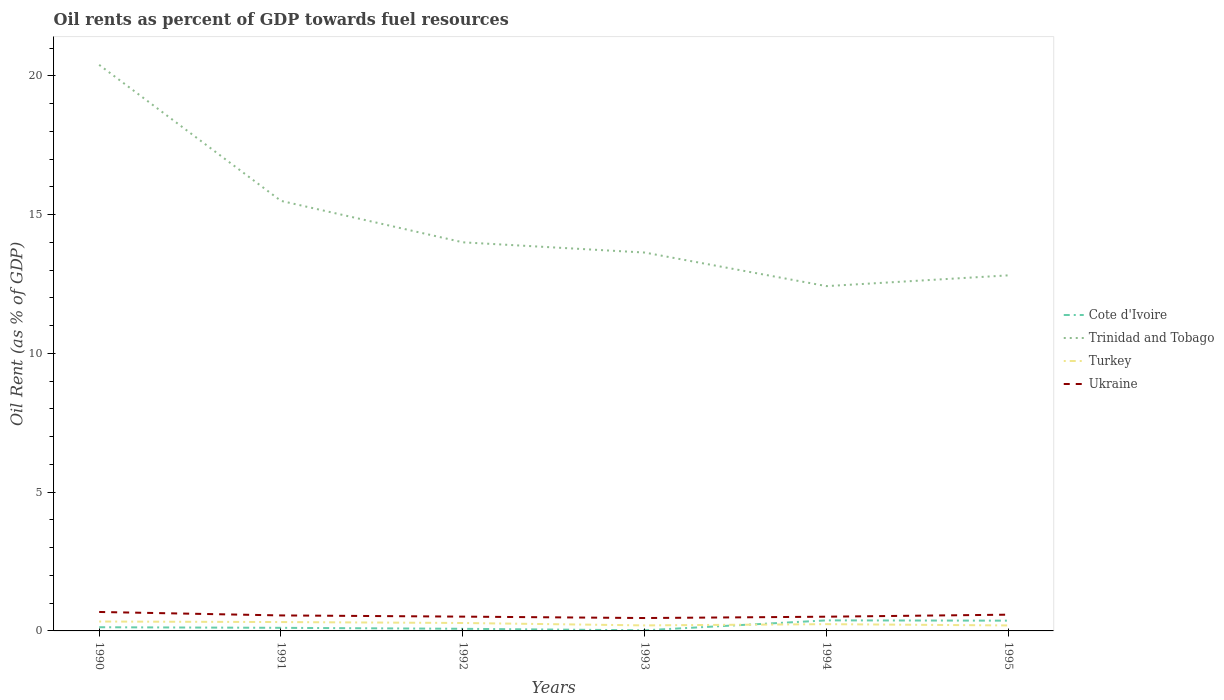Across all years, what is the maximum oil rent in Trinidad and Tobago?
Offer a very short reply. 12.42. What is the total oil rent in Turkey in the graph?
Offer a terse response. 0.12. What is the difference between the highest and the second highest oil rent in Ukraine?
Your response must be concise. 0.22. What is the difference between the highest and the lowest oil rent in Ukraine?
Make the answer very short. 3. How many lines are there?
Your answer should be compact. 4. How many years are there in the graph?
Your answer should be compact. 6. Are the values on the major ticks of Y-axis written in scientific E-notation?
Give a very brief answer. No. Does the graph contain grids?
Provide a succinct answer. No. Where does the legend appear in the graph?
Ensure brevity in your answer.  Center right. How are the legend labels stacked?
Make the answer very short. Vertical. What is the title of the graph?
Your answer should be compact. Oil rents as percent of GDP towards fuel resources. What is the label or title of the X-axis?
Give a very brief answer. Years. What is the label or title of the Y-axis?
Keep it short and to the point. Oil Rent (as % of GDP). What is the Oil Rent (as % of GDP) in Cote d'Ivoire in 1990?
Offer a very short reply. 0.13. What is the Oil Rent (as % of GDP) in Trinidad and Tobago in 1990?
Provide a short and direct response. 20.4. What is the Oil Rent (as % of GDP) of Turkey in 1990?
Your response must be concise. 0.34. What is the Oil Rent (as % of GDP) in Ukraine in 1990?
Your response must be concise. 0.68. What is the Oil Rent (as % of GDP) in Cote d'Ivoire in 1991?
Your answer should be compact. 0.11. What is the Oil Rent (as % of GDP) in Trinidad and Tobago in 1991?
Your answer should be compact. 15.5. What is the Oil Rent (as % of GDP) of Turkey in 1991?
Give a very brief answer. 0.32. What is the Oil Rent (as % of GDP) in Ukraine in 1991?
Offer a very short reply. 0.56. What is the Oil Rent (as % of GDP) of Cote d'Ivoire in 1992?
Give a very brief answer. 0.08. What is the Oil Rent (as % of GDP) of Trinidad and Tobago in 1992?
Make the answer very short. 14. What is the Oil Rent (as % of GDP) in Turkey in 1992?
Give a very brief answer. 0.29. What is the Oil Rent (as % of GDP) in Ukraine in 1992?
Ensure brevity in your answer.  0.52. What is the Oil Rent (as % of GDP) in Cote d'Ivoire in 1993?
Offer a very short reply. 0.02. What is the Oil Rent (as % of GDP) of Trinidad and Tobago in 1993?
Keep it short and to the point. 13.63. What is the Oil Rent (as % of GDP) of Turkey in 1993?
Ensure brevity in your answer.  0.2. What is the Oil Rent (as % of GDP) of Ukraine in 1993?
Keep it short and to the point. 0.46. What is the Oil Rent (as % of GDP) of Cote d'Ivoire in 1994?
Give a very brief answer. 0.38. What is the Oil Rent (as % of GDP) in Trinidad and Tobago in 1994?
Your response must be concise. 12.42. What is the Oil Rent (as % of GDP) of Turkey in 1994?
Your response must be concise. 0.24. What is the Oil Rent (as % of GDP) of Ukraine in 1994?
Ensure brevity in your answer.  0.51. What is the Oil Rent (as % of GDP) of Cote d'Ivoire in 1995?
Give a very brief answer. 0.37. What is the Oil Rent (as % of GDP) of Trinidad and Tobago in 1995?
Make the answer very short. 12.81. What is the Oil Rent (as % of GDP) of Turkey in 1995?
Your answer should be very brief. 0.2. What is the Oil Rent (as % of GDP) in Ukraine in 1995?
Provide a succinct answer. 0.59. Across all years, what is the maximum Oil Rent (as % of GDP) in Cote d'Ivoire?
Offer a very short reply. 0.38. Across all years, what is the maximum Oil Rent (as % of GDP) of Trinidad and Tobago?
Offer a terse response. 20.4. Across all years, what is the maximum Oil Rent (as % of GDP) in Turkey?
Make the answer very short. 0.34. Across all years, what is the maximum Oil Rent (as % of GDP) in Ukraine?
Your answer should be compact. 0.68. Across all years, what is the minimum Oil Rent (as % of GDP) of Cote d'Ivoire?
Provide a short and direct response. 0.02. Across all years, what is the minimum Oil Rent (as % of GDP) in Trinidad and Tobago?
Your answer should be very brief. 12.42. Across all years, what is the minimum Oil Rent (as % of GDP) in Turkey?
Your response must be concise. 0.2. Across all years, what is the minimum Oil Rent (as % of GDP) in Ukraine?
Your answer should be very brief. 0.46. What is the total Oil Rent (as % of GDP) in Cote d'Ivoire in the graph?
Ensure brevity in your answer.  1.09. What is the total Oil Rent (as % of GDP) of Trinidad and Tobago in the graph?
Your response must be concise. 88.76. What is the total Oil Rent (as % of GDP) of Turkey in the graph?
Your answer should be compact. 1.58. What is the total Oil Rent (as % of GDP) of Ukraine in the graph?
Ensure brevity in your answer.  3.32. What is the difference between the Oil Rent (as % of GDP) of Cote d'Ivoire in 1990 and that in 1991?
Ensure brevity in your answer.  0.02. What is the difference between the Oil Rent (as % of GDP) of Trinidad and Tobago in 1990 and that in 1991?
Provide a short and direct response. 4.9. What is the difference between the Oil Rent (as % of GDP) in Turkey in 1990 and that in 1991?
Offer a very short reply. 0.02. What is the difference between the Oil Rent (as % of GDP) in Ukraine in 1990 and that in 1991?
Provide a succinct answer. 0.12. What is the difference between the Oil Rent (as % of GDP) in Cote d'Ivoire in 1990 and that in 1992?
Make the answer very short. 0.06. What is the difference between the Oil Rent (as % of GDP) of Trinidad and Tobago in 1990 and that in 1992?
Your answer should be compact. 6.39. What is the difference between the Oil Rent (as % of GDP) in Turkey in 1990 and that in 1992?
Your answer should be very brief. 0.05. What is the difference between the Oil Rent (as % of GDP) of Ukraine in 1990 and that in 1992?
Keep it short and to the point. 0.17. What is the difference between the Oil Rent (as % of GDP) of Cote d'Ivoire in 1990 and that in 1993?
Make the answer very short. 0.11. What is the difference between the Oil Rent (as % of GDP) in Trinidad and Tobago in 1990 and that in 1993?
Make the answer very short. 6.76. What is the difference between the Oil Rent (as % of GDP) of Turkey in 1990 and that in 1993?
Your answer should be very brief. 0.14. What is the difference between the Oil Rent (as % of GDP) of Ukraine in 1990 and that in 1993?
Your answer should be compact. 0.22. What is the difference between the Oil Rent (as % of GDP) in Cote d'Ivoire in 1990 and that in 1994?
Offer a very short reply. -0.25. What is the difference between the Oil Rent (as % of GDP) in Trinidad and Tobago in 1990 and that in 1994?
Provide a succinct answer. 7.97. What is the difference between the Oil Rent (as % of GDP) of Turkey in 1990 and that in 1994?
Your answer should be compact. 0.09. What is the difference between the Oil Rent (as % of GDP) of Ukraine in 1990 and that in 1994?
Provide a short and direct response. 0.17. What is the difference between the Oil Rent (as % of GDP) in Cote d'Ivoire in 1990 and that in 1995?
Provide a succinct answer. -0.24. What is the difference between the Oil Rent (as % of GDP) in Trinidad and Tobago in 1990 and that in 1995?
Offer a very short reply. 7.58. What is the difference between the Oil Rent (as % of GDP) of Turkey in 1990 and that in 1995?
Your response must be concise. 0.14. What is the difference between the Oil Rent (as % of GDP) of Ukraine in 1990 and that in 1995?
Your answer should be very brief. 0.1. What is the difference between the Oil Rent (as % of GDP) of Cote d'Ivoire in 1991 and that in 1992?
Your answer should be very brief. 0.04. What is the difference between the Oil Rent (as % of GDP) in Trinidad and Tobago in 1991 and that in 1992?
Your answer should be very brief. 1.49. What is the difference between the Oil Rent (as % of GDP) of Turkey in 1991 and that in 1992?
Keep it short and to the point. 0.03. What is the difference between the Oil Rent (as % of GDP) in Ukraine in 1991 and that in 1992?
Keep it short and to the point. 0.04. What is the difference between the Oil Rent (as % of GDP) in Cote d'Ivoire in 1991 and that in 1993?
Offer a very short reply. 0.09. What is the difference between the Oil Rent (as % of GDP) of Trinidad and Tobago in 1991 and that in 1993?
Provide a short and direct response. 1.86. What is the difference between the Oil Rent (as % of GDP) of Turkey in 1991 and that in 1993?
Offer a very short reply. 0.12. What is the difference between the Oil Rent (as % of GDP) of Ukraine in 1991 and that in 1993?
Offer a terse response. 0.09. What is the difference between the Oil Rent (as % of GDP) in Cote d'Ivoire in 1991 and that in 1994?
Provide a short and direct response. -0.27. What is the difference between the Oil Rent (as % of GDP) of Trinidad and Tobago in 1991 and that in 1994?
Provide a succinct answer. 3.07. What is the difference between the Oil Rent (as % of GDP) in Turkey in 1991 and that in 1994?
Your answer should be very brief. 0.08. What is the difference between the Oil Rent (as % of GDP) in Ukraine in 1991 and that in 1994?
Offer a very short reply. 0.05. What is the difference between the Oil Rent (as % of GDP) in Cote d'Ivoire in 1991 and that in 1995?
Make the answer very short. -0.26. What is the difference between the Oil Rent (as % of GDP) in Trinidad and Tobago in 1991 and that in 1995?
Offer a terse response. 2.68. What is the difference between the Oil Rent (as % of GDP) in Turkey in 1991 and that in 1995?
Keep it short and to the point. 0.12. What is the difference between the Oil Rent (as % of GDP) of Ukraine in 1991 and that in 1995?
Your answer should be compact. -0.03. What is the difference between the Oil Rent (as % of GDP) of Cote d'Ivoire in 1992 and that in 1993?
Your response must be concise. 0.05. What is the difference between the Oil Rent (as % of GDP) in Trinidad and Tobago in 1992 and that in 1993?
Ensure brevity in your answer.  0.37. What is the difference between the Oil Rent (as % of GDP) of Turkey in 1992 and that in 1993?
Make the answer very short. 0.09. What is the difference between the Oil Rent (as % of GDP) of Ukraine in 1992 and that in 1993?
Make the answer very short. 0.05. What is the difference between the Oil Rent (as % of GDP) in Cote d'Ivoire in 1992 and that in 1994?
Make the answer very short. -0.3. What is the difference between the Oil Rent (as % of GDP) of Trinidad and Tobago in 1992 and that in 1994?
Give a very brief answer. 1.58. What is the difference between the Oil Rent (as % of GDP) of Turkey in 1992 and that in 1994?
Keep it short and to the point. 0.04. What is the difference between the Oil Rent (as % of GDP) in Ukraine in 1992 and that in 1994?
Make the answer very short. 0. What is the difference between the Oil Rent (as % of GDP) in Cote d'Ivoire in 1992 and that in 1995?
Provide a short and direct response. -0.29. What is the difference between the Oil Rent (as % of GDP) in Trinidad and Tobago in 1992 and that in 1995?
Ensure brevity in your answer.  1.19. What is the difference between the Oil Rent (as % of GDP) in Turkey in 1992 and that in 1995?
Make the answer very short. 0.09. What is the difference between the Oil Rent (as % of GDP) of Ukraine in 1992 and that in 1995?
Ensure brevity in your answer.  -0.07. What is the difference between the Oil Rent (as % of GDP) in Cote d'Ivoire in 1993 and that in 1994?
Your answer should be very brief. -0.36. What is the difference between the Oil Rent (as % of GDP) in Trinidad and Tobago in 1993 and that in 1994?
Offer a very short reply. 1.21. What is the difference between the Oil Rent (as % of GDP) in Turkey in 1993 and that in 1994?
Your answer should be very brief. -0.04. What is the difference between the Oil Rent (as % of GDP) of Ukraine in 1993 and that in 1994?
Keep it short and to the point. -0.05. What is the difference between the Oil Rent (as % of GDP) of Cote d'Ivoire in 1993 and that in 1995?
Your answer should be very brief. -0.35. What is the difference between the Oil Rent (as % of GDP) in Trinidad and Tobago in 1993 and that in 1995?
Provide a succinct answer. 0.82. What is the difference between the Oil Rent (as % of GDP) of Turkey in 1993 and that in 1995?
Keep it short and to the point. 0. What is the difference between the Oil Rent (as % of GDP) in Ukraine in 1993 and that in 1995?
Keep it short and to the point. -0.12. What is the difference between the Oil Rent (as % of GDP) in Cote d'Ivoire in 1994 and that in 1995?
Offer a terse response. 0.01. What is the difference between the Oil Rent (as % of GDP) in Trinidad and Tobago in 1994 and that in 1995?
Your answer should be compact. -0.39. What is the difference between the Oil Rent (as % of GDP) of Turkey in 1994 and that in 1995?
Make the answer very short. 0.05. What is the difference between the Oil Rent (as % of GDP) in Ukraine in 1994 and that in 1995?
Your answer should be compact. -0.07. What is the difference between the Oil Rent (as % of GDP) of Cote d'Ivoire in 1990 and the Oil Rent (as % of GDP) of Trinidad and Tobago in 1991?
Provide a succinct answer. -15.36. What is the difference between the Oil Rent (as % of GDP) in Cote d'Ivoire in 1990 and the Oil Rent (as % of GDP) in Turkey in 1991?
Provide a succinct answer. -0.19. What is the difference between the Oil Rent (as % of GDP) of Cote d'Ivoire in 1990 and the Oil Rent (as % of GDP) of Ukraine in 1991?
Make the answer very short. -0.43. What is the difference between the Oil Rent (as % of GDP) in Trinidad and Tobago in 1990 and the Oil Rent (as % of GDP) in Turkey in 1991?
Provide a succinct answer. 20.08. What is the difference between the Oil Rent (as % of GDP) in Trinidad and Tobago in 1990 and the Oil Rent (as % of GDP) in Ukraine in 1991?
Your answer should be very brief. 19.84. What is the difference between the Oil Rent (as % of GDP) of Turkey in 1990 and the Oil Rent (as % of GDP) of Ukraine in 1991?
Make the answer very short. -0.22. What is the difference between the Oil Rent (as % of GDP) of Cote d'Ivoire in 1990 and the Oil Rent (as % of GDP) of Trinidad and Tobago in 1992?
Ensure brevity in your answer.  -13.87. What is the difference between the Oil Rent (as % of GDP) in Cote d'Ivoire in 1990 and the Oil Rent (as % of GDP) in Turkey in 1992?
Your answer should be compact. -0.15. What is the difference between the Oil Rent (as % of GDP) in Cote d'Ivoire in 1990 and the Oil Rent (as % of GDP) in Ukraine in 1992?
Keep it short and to the point. -0.38. What is the difference between the Oil Rent (as % of GDP) in Trinidad and Tobago in 1990 and the Oil Rent (as % of GDP) in Turkey in 1992?
Keep it short and to the point. 20.11. What is the difference between the Oil Rent (as % of GDP) of Trinidad and Tobago in 1990 and the Oil Rent (as % of GDP) of Ukraine in 1992?
Make the answer very short. 19.88. What is the difference between the Oil Rent (as % of GDP) of Turkey in 1990 and the Oil Rent (as % of GDP) of Ukraine in 1992?
Your response must be concise. -0.18. What is the difference between the Oil Rent (as % of GDP) in Cote d'Ivoire in 1990 and the Oil Rent (as % of GDP) in Trinidad and Tobago in 1993?
Make the answer very short. -13.5. What is the difference between the Oil Rent (as % of GDP) in Cote d'Ivoire in 1990 and the Oil Rent (as % of GDP) in Turkey in 1993?
Your answer should be compact. -0.07. What is the difference between the Oil Rent (as % of GDP) in Cote d'Ivoire in 1990 and the Oil Rent (as % of GDP) in Ukraine in 1993?
Make the answer very short. -0.33. What is the difference between the Oil Rent (as % of GDP) of Trinidad and Tobago in 1990 and the Oil Rent (as % of GDP) of Turkey in 1993?
Provide a short and direct response. 20.2. What is the difference between the Oil Rent (as % of GDP) in Trinidad and Tobago in 1990 and the Oil Rent (as % of GDP) in Ukraine in 1993?
Offer a very short reply. 19.93. What is the difference between the Oil Rent (as % of GDP) of Turkey in 1990 and the Oil Rent (as % of GDP) of Ukraine in 1993?
Give a very brief answer. -0.13. What is the difference between the Oil Rent (as % of GDP) of Cote d'Ivoire in 1990 and the Oil Rent (as % of GDP) of Trinidad and Tobago in 1994?
Provide a short and direct response. -12.29. What is the difference between the Oil Rent (as % of GDP) of Cote d'Ivoire in 1990 and the Oil Rent (as % of GDP) of Turkey in 1994?
Offer a very short reply. -0.11. What is the difference between the Oil Rent (as % of GDP) in Cote d'Ivoire in 1990 and the Oil Rent (as % of GDP) in Ukraine in 1994?
Give a very brief answer. -0.38. What is the difference between the Oil Rent (as % of GDP) of Trinidad and Tobago in 1990 and the Oil Rent (as % of GDP) of Turkey in 1994?
Offer a very short reply. 20.15. What is the difference between the Oil Rent (as % of GDP) in Trinidad and Tobago in 1990 and the Oil Rent (as % of GDP) in Ukraine in 1994?
Your answer should be compact. 19.88. What is the difference between the Oil Rent (as % of GDP) in Turkey in 1990 and the Oil Rent (as % of GDP) in Ukraine in 1994?
Offer a very short reply. -0.17. What is the difference between the Oil Rent (as % of GDP) in Cote d'Ivoire in 1990 and the Oil Rent (as % of GDP) in Trinidad and Tobago in 1995?
Offer a terse response. -12.68. What is the difference between the Oil Rent (as % of GDP) of Cote d'Ivoire in 1990 and the Oil Rent (as % of GDP) of Turkey in 1995?
Offer a very short reply. -0.06. What is the difference between the Oil Rent (as % of GDP) in Cote d'Ivoire in 1990 and the Oil Rent (as % of GDP) in Ukraine in 1995?
Ensure brevity in your answer.  -0.45. What is the difference between the Oil Rent (as % of GDP) of Trinidad and Tobago in 1990 and the Oil Rent (as % of GDP) of Turkey in 1995?
Ensure brevity in your answer.  20.2. What is the difference between the Oil Rent (as % of GDP) in Trinidad and Tobago in 1990 and the Oil Rent (as % of GDP) in Ukraine in 1995?
Provide a short and direct response. 19.81. What is the difference between the Oil Rent (as % of GDP) in Turkey in 1990 and the Oil Rent (as % of GDP) in Ukraine in 1995?
Keep it short and to the point. -0.25. What is the difference between the Oil Rent (as % of GDP) of Cote d'Ivoire in 1991 and the Oil Rent (as % of GDP) of Trinidad and Tobago in 1992?
Make the answer very short. -13.89. What is the difference between the Oil Rent (as % of GDP) in Cote d'Ivoire in 1991 and the Oil Rent (as % of GDP) in Turkey in 1992?
Make the answer very short. -0.17. What is the difference between the Oil Rent (as % of GDP) of Cote d'Ivoire in 1991 and the Oil Rent (as % of GDP) of Ukraine in 1992?
Provide a succinct answer. -0.4. What is the difference between the Oil Rent (as % of GDP) in Trinidad and Tobago in 1991 and the Oil Rent (as % of GDP) in Turkey in 1992?
Provide a short and direct response. 15.21. What is the difference between the Oil Rent (as % of GDP) in Trinidad and Tobago in 1991 and the Oil Rent (as % of GDP) in Ukraine in 1992?
Make the answer very short. 14.98. What is the difference between the Oil Rent (as % of GDP) in Turkey in 1991 and the Oil Rent (as % of GDP) in Ukraine in 1992?
Ensure brevity in your answer.  -0.2. What is the difference between the Oil Rent (as % of GDP) of Cote d'Ivoire in 1991 and the Oil Rent (as % of GDP) of Trinidad and Tobago in 1993?
Ensure brevity in your answer.  -13.52. What is the difference between the Oil Rent (as % of GDP) of Cote d'Ivoire in 1991 and the Oil Rent (as % of GDP) of Turkey in 1993?
Your answer should be compact. -0.09. What is the difference between the Oil Rent (as % of GDP) in Cote d'Ivoire in 1991 and the Oil Rent (as % of GDP) in Ukraine in 1993?
Your answer should be very brief. -0.35. What is the difference between the Oil Rent (as % of GDP) in Trinidad and Tobago in 1991 and the Oil Rent (as % of GDP) in Turkey in 1993?
Ensure brevity in your answer.  15.3. What is the difference between the Oil Rent (as % of GDP) in Trinidad and Tobago in 1991 and the Oil Rent (as % of GDP) in Ukraine in 1993?
Ensure brevity in your answer.  15.03. What is the difference between the Oil Rent (as % of GDP) of Turkey in 1991 and the Oil Rent (as % of GDP) of Ukraine in 1993?
Provide a short and direct response. -0.14. What is the difference between the Oil Rent (as % of GDP) of Cote d'Ivoire in 1991 and the Oil Rent (as % of GDP) of Trinidad and Tobago in 1994?
Offer a very short reply. -12.31. What is the difference between the Oil Rent (as % of GDP) in Cote d'Ivoire in 1991 and the Oil Rent (as % of GDP) in Turkey in 1994?
Offer a very short reply. -0.13. What is the difference between the Oil Rent (as % of GDP) in Cote d'Ivoire in 1991 and the Oil Rent (as % of GDP) in Ukraine in 1994?
Give a very brief answer. -0.4. What is the difference between the Oil Rent (as % of GDP) of Trinidad and Tobago in 1991 and the Oil Rent (as % of GDP) of Turkey in 1994?
Your answer should be very brief. 15.25. What is the difference between the Oil Rent (as % of GDP) of Trinidad and Tobago in 1991 and the Oil Rent (as % of GDP) of Ukraine in 1994?
Offer a very short reply. 14.98. What is the difference between the Oil Rent (as % of GDP) in Turkey in 1991 and the Oil Rent (as % of GDP) in Ukraine in 1994?
Give a very brief answer. -0.19. What is the difference between the Oil Rent (as % of GDP) in Cote d'Ivoire in 1991 and the Oil Rent (as % of GDP) in Trinidad and Tobago in 1995?
Offer a very short reply. -12.7. What is the difference between the Oil Rent (as % of GDP) of Cote d'Ivoire in 1991 and the Oil Rent (as % of GDP) of Turkey in 1995?
Provide a short and direct response. -0.09. What is the difference between the Oil Rent (as % of GDP) in Cote d'Ivoire in 1991 and the Oil Rent (as % of GDP) in Ukraine in 1995?
Give a very brief answer. -0.47. What is the difference between the Oil Rent (as % of GDP) of Trinidad and Tobago in 1991 and the Oil Rent (as % of GDP) of Turkey in 1995?
Offer a terse response. 15.3. What is the difference between the Oil Rent (as % of GDP) of Trinidad and Tobago in 1991 and the Oil Rent (as % of GDP) of Ukraine in 1995?
Your answer should be compact. 14.91. What is the difference between the Oil Rent (as % of GDP) of Turkey in 1991 and the Oil Rent (as % of GDP) of Ukraine in 1995?
Your answer should be compact. -0.27. What is the difference between the Oil Rent (as % of GDP) in Cote d'Ivoire in 1992 and the Oil Rent (as % of GDP) in Trinidad and Tobago in 1993?
Your answer should be very brief. -13.56. What is the difference between the Oil Rent (as % of GDP) of Cote d'Ivoire in 1992 and the Oil Rent (as % of GDP) of Turkey in 1993?
Keep it short and to the point. -0.12. What is the difference between the Oil Rent (as % of GDP) of Cote d'Ivoire in 1992 and the Oil Rent (as % of GDP) of Ukraine in 1993?
Give a very brief answer. -0.39. What is the difference between the Oil Rent (as % of GDP) in Trinidad and Tobago in 1992 and the Oil Rent (as % of GDP) in Turkey in 1993?
Give a very brief answer. 13.8. What is the difference between the Oil Rent (as % of GDP) of Trinidad and Tobago in 1992 and the Oil Rent (as % of GDP) of Ukraine in 1993?
Your response must be concise. 13.54. What is the difference between the Oil Rent (as % of GDP) in Turkey in 1992 and the Oil Rent (as % of GDP) in Ukraine in 1993?
Provide a succinct answer. -0.18. What is the difference between the Oil Rent (as % of GDP) in Cote d'Ivoire in 1992 and the Oil Rent (as % of GDP) in Trinidad and Tobago in 1994?
Provide a short and direct response. -12.35. What is the difference between the Oil Rent (as % of GDP) in Cote d'Ivoire in 1992 and the Oil Rent (as % of GDP) in Turkey in 1994?
Offer a very short reply. -0.17. What is the difference between the Oil Rent (as % of GDP) of Cote d'Ivoire in 1992 and the Oil Rent (as % of GDP) of Ukraine in 1994?
Your answer should be very brief. -0.44. What is the difference between the Oil Rent (as % of GDP) of Trinidad and Tobago in 1992 and the Oil Rent (as % of GDP) of Turkey in 1994?
Your response must be concise. 13.76. What is the difference between the Oil Rent (as % of GDP) in Trinidad and Tobago in 1992 and the Oil Rent (as % of GDP) in Ukraine in 1994?
Your answer should be compact. 13.49. What is the difference between the Oil Rent (as % of GDP) in Turkey in 1992 and the Oil Rent (as % of GDP) in Ukraine in 1994?
Your response must be concise. -0.23. What is the difference between the Oil Rent (as % of GDP) in Cote d'Ivoire in 1992 and the Oil Rent (as % of GDP) in Trinidad and Tobago in 1995?
Provide a succinct answer. -12.74. What is the difference between the Oil Rent (as % of GDP) of Cote d'Ivoire in 1992 and the Oil Rent (as % of GDP) of Turkey in 1995?
Make the answer very short. -0.12. What is the difference between the Oil Rent (as % of GDP) of Cote d'Ivoire in 1992 and the Oil Rent (as % of GDP) of Ukraine in 1995?
Provide a succinct answer. -0.51. What is the difference between the Oil Rent (as % of GDP) of Trinidad and Tobago in 1992 and the Oil Rent (as % of GDP) of Turkey in 1995?
Make the answer very short. 13.8. What is the difference between the Oil Rent (as % of GDP) in Trinidad and Tobago in 1992 and the Oil Rent (as % of GDP) in Ukraine in 1995?
Provide a succinct answer. 13.42. What is the difference between the Oil Rent (as % of GDP) of Turkey in 1992 and the Oil Rent (as % of GDP) of Ukraine in 1995?
Your response must be concise. -0.3. What is the difference between the Oil Rent (as % of GDP) in Cote d'Ivoire in 1993 and the Oil Rent (as % of GDP) in Trinidad and Tobago in 1994?
Your answer should be compact. -12.4. What is the difference between the Oil Rent (as % of GDP) of Cote d'Ivoire in 1993 and the Oil Rent (as % of GDP) of Turkey in 1994?
Offer a terse response. -0.22. What is the difference between the Oil Rent (as % of GDP) of Cote d'Ivoire in 1993 and the Oil Rent (as % of GDP) of Ukraine in 1994?
Keep it short and to the point. -0.49. What is the difference between the Oil Rent (as % of GDP) in Trinidad and Tobago in 1993 and the Oil Rent (as % of GDP) in Turkey in 1994?
Your answer should be very brief. 13.39. What is the difference between the Oil Rent (as % of GDP) in Trinidad and Tobago in 1993 and the Oil Rent (as % of GDP) in Ukraine in 1994?
Your answer should be compact. 13.12. What is the difference between the Oil Rent (as % of GDP) of Turkey in 1993 and the Oil Rent (as % of GDP) of Ukraine in 1994?
Give a very brief answer. -0.31. What is the difference between the Oil Rent (as % of GDP) of Cote d'Ivoire in 1993 and the Oil Rent (as % of GDP) of Trinidad and Tobago in 1995?
Provide a short and direct response. -12.79. What is the difference between the Oil Rent (as % of GDP) in Cote d'Ivoire in 1993 and the Oil Rent (as % of GDP) in Turkey in 1995?
Provide a short and direct response. -0.18. What is the difference between the Oil Rent (as % of GDP) of Cote d'Ivoire in 1993 and the Oil Rent (as % of GDP) of Ukraine in 1995?
Provide a succinct answer. -0.56. What is the difference between the Oil Rent (as % of GDP) in Trinidad and Tobago in 1993 and the Oil Rent (as % of GDP) in Turkey in 1995?
Keep it short and to the point. 13.44. What is the difference between the Oil Rent (as % of GDP) in Trinidad and Tobago in 1993 and the Oil Rent (as % of GDP) in Ukraine in 1995?
Offer a very short reply. 13.05. What is the difference between the Oil Rent (as % of GDP) in Turkey in 1993 and the Oil Rent (as % of GDP) in Ukraine in 1995?
Make the answer very short. -0.39. What is the difference between the Oil Rent (as % of GDP) in Cote d'Ivoire in 1994 and the Oil Rent (as % of GDP) in Trinidad and Tobago in 1995?
Make the answer very short. -12.43. What is the difference between the Oil Rent (as % of GDP) of Cote d'Ivoire in 1994 and the Oil Rent (as % of GDP) of Turkey in 1995?
Provide a succinct answer. 0.18. What is the difference between the Oil Rent (as % of GDP) in Cote d'Ivoire in 1994 and the Oil Rent (as % of GDP) in Ukraine in 1995?
Provide a short and direct response. -0.21. What is the difference between the Oil Rent (as % of GDP) of Trinidad and Tobago in 1994 and the Oil Rent (as % of GDP) of Turkey in 1995?
Your answer should be very brief. 12.23. What is the difference between the Oil Rent (as % of GDP) of Trinidad and Tobago in 1994 and the Oil Rent (as % of GDP) of Ukraine in 1995?
Your answer should be very brief. 11.84. What is the difference between the Oil Rent (as % of GDP) in Turkey in 1994 and the Oil Rent (as % of GDP) in Ukraine in 1995?
Your answer should be compact. -0.34. What is the average Oil Rent (as % of GDP) of Cote d'Ivoire per year?
Provide a short and direct response. 0.18. What is the average Oil Rent (as % of GDP) in Trinidad and Tobago per year?
Offer a terse response. 14.79. What is the average Oil Rent (as % of GDP) of Turkey per year?
Offer a terse response. 0.26. What is the average Oil Rent (as % of GDP) of Ukraine per year?
Your response must be concise. 0.55. In the year 1990, what is the difference between the Oil Rent (as % of GDP) of Cote d'Ivoire and Oil Rent (as % of GDP) of Trinidad and Tobago?
Ensure brevity in your answer.  -20.26. In the year 1990, what is the difference between the Oil Rent (as % of GDP) of Cote d'Ivoire and Oil Rent (as % of GDP) of Turkey?
Keep it short and to the point. -0.21. In the year 1990, what is the difference between the Oil Rent (as % of GDP) in Cote d'Ivoire and Oil Rent (as % of GDP) in Ukraine?
Your answer should be very brief. -0.55. In the year 1990, what is the difference between the Oil Rent (as % of GDP) in Trinidad and Tobago and Oil Rent (as % of GDP) in Turkey?
Offer a terse response. 20.06. In the year 1990, what is the difference between the Oil Rent (as % of GDP) in Trinidad and Tobago and Oil Rent (as % of GDP) in Ukraine?
Your answer should be compact. 19.71. In the year 1990, what is the difference between the Oil Rent (as % of GDP) in Turkey and Oil Rent (as % of GDP) in Ukraine?
Give a very brief answer. -0.34. In the year 1991, what is the difference between the Oil Rent (as % of GDP) of Cote d'Ivoire and Oil Rent (as % of GDP) of Trinidad and Tobago?
Your response must be concise. -15.38. In the year 1991, what is the difference between the Oil Rent (as % of GDP) of Cote d'Ivoire and Oil Rent (as % of GDP) of Turkey?
Offer a terse response. -0.21. In the year 1991, what is the difference between the Oil Rent (as % of GDP) in Cote d'Ivoire and Oil Rent (as % of GDP) in Ukraine?
Your response must be concise. -0.45. In the year 1991, what is the difference between the Oil Rent (as % of GDP) in Trinidad and Tobago and Oil Rent (as % of GDP) in Turkey?
Offer a very short reply. 15.18. In the year 1991, what is the difference between the Oil Rent (as % of GDP) of Trinidad and Tobago and Oil Rent (as % of GDP) of Ukraine?
Keep it short and to the point. 14.94. In the year 1991, what is the difference between the Oil Rent (as % of GDP) of Turkey and Oil Rent (as % of GDP) of Ukraine?
Your answer should be very brief. -0.24. In the year 1992, what is the difference between the Oil Rent (as % of GDP) in Cote d'Ivoire and Oil Rent (as % of GDP) in Trinidad and Tobago?
Make the answer very short. -13.93. In the year 1992, what is the difference between the Oil Rent (as % of GDP) in Cote d'Ivoire and Oil Rent (as % of GDP) in Turkey?
Your response must be concise. -0.21. In the year 1992, what is the difference between the Oil Rent (as % of GDP) in Cote d'Ivoire and Oil Rent (as % of GDP) in Ukraine?
Make the answer very short. -0.44. In the year 1992, what is the difference between the Oil Rent (as % of GDP) of Trinidad and Tobago and Oil Rent (as % of GDP) of Turkey?
Provide a succinct answer. 13.72. In the year 1992, what is the difference between the Oil Rent (as % of GDP) in Trinidad and Tobago and Oil Rent (as % of GDP) in Ukraine?
Ensure brevity in your answer.  13.49. In the year 1992, what is the difference between the Oil Rent (as % of GDP) in Turkey and Oil Rent (as % of GDP) in Ukraine?
Provide a short and direct response. -0.23. In the year 1993, what is the difference between the Oil Rent (as % of GDP) of Cote d'Ivoire and Oil Rent (as % of GDP) of Trinidad and Tobago?
Your answer should be very brief. -13.61. In the year 1993, what is the difference between the Oil Rent (as % of GDP) of Cote d'Ivoire and Oil Rent (as % of GDP) of Turkey?
Your response must be concise. -0.18. In the year 1993, what is the difference between the Oil Rent (as % of GDP) in Cote d'Ivoire and Oil Rent (as % of GDP) in Ukraine?
Give a very brief answer. -0.44. In the year 1993, what is the difference between the Oil Rent (as % of GDP) of Trinidad and Tobago and Oil Rent (as % of GDP) of Turkey?
Your response must be concise. 13.43. In the year 1993, what is the difference between the Oil Rent (as % of GDP) in Trinidad and Tobago and Oil Rent (as % of GDP) in Ukraine?
Make the answer very short. 13.17. In the year 1993, what is the difference between the Oil Rent (as % of GDP) of Turkey and Oil Rent (as % of GDP) of Ukraine?
Your answer should be compact. -0.27. In the year 1994, what is the difference between the Oil Rent (as % of GDP) of Cote d'Ivoire and Oil Rent (as % of GDP) of Trinidad and Tobago?
Make the answer very short. -12.04. In the year 1994, what is the difference between the Oil Rent (as % of GDP) in Cote d'Ivoire and Oil Rent (as % of GDP) in Turkey?
Provide a short and direct response. 0.14. In the year 1994, what is the difference between the Oil Rent (as % of GDP) of Cote d'Ivoire and Oil Rent (as % of GDP) of Ukraine?
Keep it short and to the point. -0.13. In the year 1994, what is the difference between the Oil Rent (as % of GDP) in Trinidad and Tobago and Oil Rent (as % of GDP) in Turkey?
Give a very brief answer. 12.18. In the year 1994, what is the difference between the Oil Rent (as % of GDP) in Trinidad and Tobago and Oil Rent (as % of GDP) in Ukraine?
Provide a succinct answer. 11.91. In the year 1994, what is the difference between the Oil Rent (as % of GDP) in Turkey and Oil Rent (as % of GDP) in Ukraine?
Make the answer very short. -0.27. In the year 1995, what is the difference between the Oil Rent (as % of GDP) in Cote d'Ivoire and Oil Rent (as % of GDP) in Trinidad and Tobago?
Your answer should be very brief. -12.44. In the year 1995, what is the difference between the Oil Rent (as % of GDP) of Cote d'Ivoire and Oil Rent (as % of GDP) of Turkey?
Offer a terse response. 0.17. In the year 1995, what is the difference between the Oil Rent (as % of GDP) of Cote d'Ivoire and Oil Rent (as % of GDP) of Ukraine?
Your answer should be very brief. -0.22. In the year 1995, what is the difference between the Oil Rent (as % of GDP) in Trinidad and Tobago and Oil Rent (as % of GDP) in Turkey?
Keep it short and to the point. 12.61. In the year 1995, what is the difference between the Oil Rent (as % of GDP) of Trinidad and Tobago and Oil Rent (as % of GDP) of Ukraine?
Provide a short and direct response. 12.23. In the year 1995, what is the difference between the Oil Rent (as % of GDP) of Turkey and Oil Rent (as % of GDP) of Ukraine?
Your response must be concise. -0.39. What is the ratio of the Oil Rent (as % of GDP) in Cote d'Ivoire in 1990 to that in 1991?
Your answer should be compact. 1.19. What is the ratio of the Oil Rent (as % of GDP) of Trinidad and Tobago in 1990 to that in 1991?
Make the answer very short. 1.32. What is the ratio of the Oil Rent (as % of GDP) of Turkey in 1990 to that in 1991?
Keep it short and to the point. 1.06. What is the ratio of the Oil Rent (as % of GDP) in Ukraine in 1990 to that in 1991?
Offer a terse response. 1.22. What is the ratio of the Oil Rent (as % of GDP) of Cote d'Ivoire in 1990 to that in 1992?
Provide a short and direct response. 1.74. What is the ratio of the Oil Rent (as % of GDP) of Trinidad and Tobago in 1990 to that in 1992?
Make the answer very short. 1.46. What is the ratio of the Oil Rent (as % of GDP) of Turkey in 1990 to that in 1992?
Offer a terse response. 1.18. What is the ratio of the Oil Rent (as % of GDP) in Ukraine in 1990 to that in 1992?
Offer a terse response. 1.33. What is the ratio of the Oil Rent (as % of GDP) in Cote d'Ivoire in 1990 to that in 1993?
Give a very brief answer. 5.93. What is the ratio of the Oil Rent (as % of GDP) of Trinidad and Tobago in 1990 to that in 1993?
Your response must be concise. 1.5. What is the ratio of the Oil Rent (as % of GDP) of Turkey in 1990 to that in 1993?
Make the answer very short. 1.7. What is the ratio of the Oil Rent (as % of GDP) of Ukraine in 1990 to that in 1993?
Offer a very short reply. 1.47. What is the ratio of the Oil Rent (as % of GDP) of Cote d'Ivoire in 1990 to that in 1994?
Your answer should be very brief. 0.35. What is the ratio of the Oil Rent (as % of GDP) of Trinidad and Tobago in 1990 to that in 1994?
Offer a very short reply. 1.64. What is the ratio of the Oil Rent (as % of GDP) of Turkey in 1990 to that in 1994?
Your answer should be compact. 1.39. What is the ratio of the Oil Rent (as % of GDP) in Ukraine in 1990 to that in 1994?
Keep it short and to the point. 1.33. What is the ratio of the Oil Rent (as % of GDP) in Cote d'Ivoire in 1990 to that in 1995?
Your answer should be very brief. 0.36. What is the ratio of the Oil Rent (as % of GDP) in Trinidad and Tobago in 1990 to that in 1995?
Give a very brief answer. 1.59. What is the ratio of the Oil Rent (as % of GDP) of Turkey in 1990 to that in 1995?
Keep it short and to the point. 1.71. What is the ratio of the Oil Rent (as % of GDP) in Ukraine in 1990 to that in 1995?
Give a very brief answer. 1.17. What is the ratio of the Oil Rent (as % of GDP) in Cote d'Ivoire in 1991 to that in 1992?
Ensure brevity in your answer.  1.46. What is the ratio of the Oil Rent (as % of GDP) in Trinidad and Tobago in 1991 to that in 1992?
Your answer should be compact. 1.11. What is the ratio of the Oil Rent (as % of GDP) in Turkey in 1991 to that in 1992?
Your answer should be compact. 1.12. What is the ratio of the Oil Rent (as % of GDP) in Ukraine in 1991 to that in 1992?
Give a very brief answer. 1.08. What is the ratio of the Oil Rent (as % of GDP) in Cote d'Ivoire in 1991 to that in 1993?
Make the answer very short. 4.99. What is the ratio of the Oil Rent (as % of GDP) in Trinidad and Tobago in 1991 to that in 1993?
Provide a short and direct response. 1.14. What is the ratio of the Oil Rent (as % of GDP) of Turkey in 1991 to that in 1993?
Keep it short and to the point. 1.61. What is the ratio of the Oil Rent (as % of GDP) in Ukraine in 1991 to that in 1993?
Give a very brief answer. 1.2. What is the ratio of the Oil Rent (as % of GDP) of Cote d'Ivoire in 1991 to that in 1994?
Offer a very short reply. 0.29. What is the ratio of the Oil Rent (as % of GDP) in Trinidad and Tobago in 1991 to that in 1994?
Your response must be concise. 1.25. What is the ratio of the Oil Rent (as % of GDP) in Turkey in 1991 to that in 1994?
Offer a very short reply. 1.31. What is the ratio of the Oil Rent (as % of GDP) of Ukraine in 1991 to that in 1994?
Your answer should be very brief. 1.09. What is the ratio of the Oil Rent (as % of GDP) of Cote d'Ivoire in 1991 to that in 1995?
Make the answer very short. 0.3. What is the ratio of the Oil Rent (as % of GDP) in Trinidad and Tobago in 1991 to that in 1995?
Your answer should be very brief. 1.21. What is the ratio of the Oil Rent (as % of GDP) of Turkey in 1991 to that in 1995?
Your answer should be compact. 1.62. What is the ratio of the Oil Rent (as % of GDP) in Ukraine in 1991 to that in 1995?
Your response must be concise. 0.95. What is the ratio of the Oil Rent (as % of GDP) of Cote d'Ivoire in 1992 to that in 1993?
Provide a succinct answer. 3.41. What is the ratio of the Oil Rent (as % of GDP) of Turkey in 1992 to that in 1993?
Your answer should be compact. 1.44. What is the ratio of the Oil Rent (as % of GDP) in Ukraine in 1992 to that in 1993?
Offer a very short reply. 1.11. What is the ratio of the Oil Rent (as % of GDP) of Cote d'Ivoire in 1992 to that in 1994?
Offer a terse response. 0.2. What is the ratio of the Oil Rent (as % of GDP) of Trinidad and Tobago in 1992 to that in 1994?
Offer a terse response. 1.13. What is the ratio of the Oil Rent (as % of GDP) in Turkey in 1992 to that in 1994?
Offer a terse response. 1.17. What is the ratio of the Oil Rent (as % of GDP) of Ukraine in 1992 to that in 1994?
Offer a very short reply. 1. What is the ratio of the Oil Rent (as % of GDP) in Cote d'Ivoire in 1992 to that in 1995?
Keep it short and to the point. 0.21. What is the ratio of the Oil Rent (as % of GDP) of Trinidad and Tobago in 1992 to that in 1995?
Offer a terse response. 1.09. What is the ratio of the Oil Rent (as % of GDP) in Turkey in 1992 to that in 1995?
Offer a very short reply. 1.45. What is the ratio of the Oil Rent (as % of GDP) of Ukraine in 1992 to that in 1995?
Keep it short and to the point. 0.88. What is the ratio of the Oil Rent (as % of GDP) in Cote d'Ivoire in 1993 to that in 1994?
Your answer should be very brief. 0.06. What is the ratio of the Oil Rent (as % of GDP) in Trinidad and Tobago in 1993 to that in 1994?
Provide a succinct answer. 1.1. What is the ratio of the Oil Rent (as % of GDP) in Turkey in 1993 to that in 1994?
Your answer should be very brief. 0.82. What is the ratio of the Oil Rent (as % of GDP) in Ukraine in 1993 to that in 1994?
Provide a short and direct response. 0.91. What is the ratio of the Oil Rent (as % of GDP) of Cote d'Ivoire in 1993 to that in 1995?
Your response must be concise. 0.06. What is the ratio of the Oil Rent (as % of GDP) of Trinidad and Tobago in 1993 to that in 1995?
Offer a terse response. 1.06. What is the ratio of the Oil Rent (as % of GDP) in Turkey in 1993 to that in 1995?
Your response must be concise. 1.01. What is the ratio of the Oil Rent (as % of GDP) in Ukraine in 1993 to that in 1995?
Keep it short and to the point. 0.79. What is the ratio of the Oil Rent (as % of GDP) of Cote d'Ivoire in 1994 to that in 1995?
Give a very brief answer. 1.03. What is the ratio of the Oil Rent (as % of GDP) of Trinidad and Tobago in 1994 to that in 1995?
Make the answer very short. 0.97. What is the ratio of the Oil Rent (as % of GDP) in Turkey in 1994 to that in 1995?
Keep it short and to the point. 1.23. What is the ratio of the Oil Rent (as % of GDP) of Ukraine in 1994 to that in 1995?
Give a very brief answer. 0.88. What is the difference between the highest and the second highest Oil Rent (as % of GDP) of Cote d'Ivoire?
Offer a very short reply. 0.01. What is the difference between the highest and the second highest Oil Rent (as % of GDP) of Trinidad and Tobago?
Your response must be concise. 4.9. What is the difference between the highest and the second highest Oil Rent (as % of GDP) of Turkey?
Give a very brief answer. 0.02. What is the difference between the highest and the second highest Oil Rent (as % of GDP) of Ukraine?
Make the answer very short. 0.1. What is the difference between the highest and the lowest Oil Rent (as % of GDP) in Cote d'Ivoire?
Provide a short and direct response. 0.36. What is the difference between the highest and the lowest Oil Rent (as % of GDP) of Trinidad and Tobago?
Ensure brevity in your answer.  7.97. What is the difference between the highest and the lowest Oil Rent (as % of GDP) in Turkey?
Provide a succinct answer. 0.14. What is the difference between the highest and the lowest Oil Rent (as % of GDP) in Ukraine?
Provide a succinct answer. 0.22. 